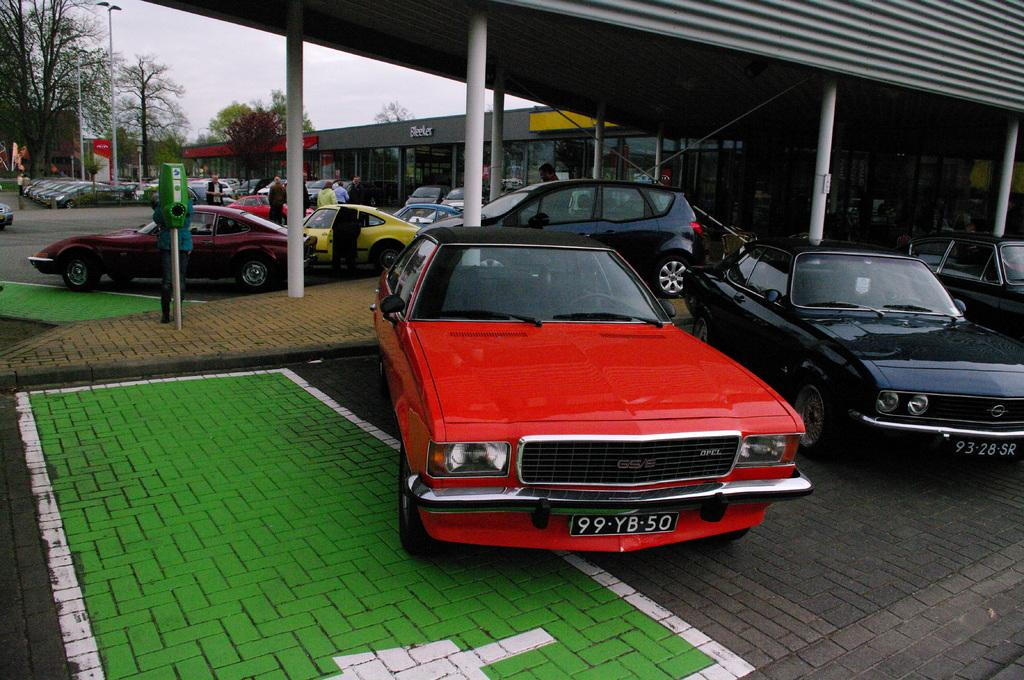What type of vehicles can be seen on the ground in the image? There are cars on the ground in the image. What architectural features are present in the image? There are pillars, buildings, and poles in the image. What type of vegetation is visible in the image? There are trees in the image. What else is present in the image besides the mentioned objects? There are flags and persons standing in the image. What can be seen in the background of the image? The sky is visible in the background of the image. Can you tell me how many friends are swimming in the sea in the image? There is no sea or friends present in the image. What type of lift is being used by the persons in the image? There is no lift present in the image; the persons are standing on the ground. 